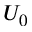Convert formula to latex. <formula><loc_0><loc_0><loc_500><loc_500>U _ { 0 }</formula> 